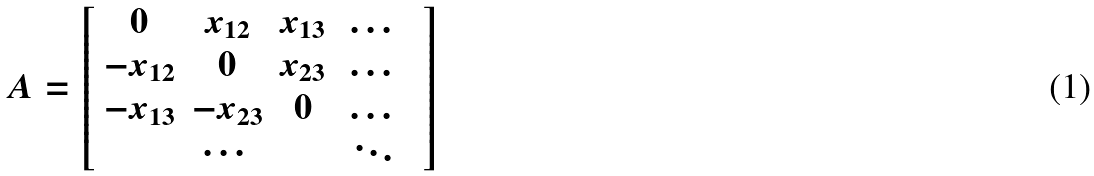<formula> <loc_0><loc_0><loc_500><loc_500>A = \left [ \begin{array} { c c c c c } 0 & x _ { 1 2 } & x _ { 1 3 } & \, \dots & \\ - x _ { 1 2 } & 0 & x _ { 2 3 } & \, \dots & \\ - x _ { 1 3 } & - x _ { 2 3 } & 0 & \, \dots & \\ & \cdots & & \, \ddots & \end{array} \right ]</formula> 